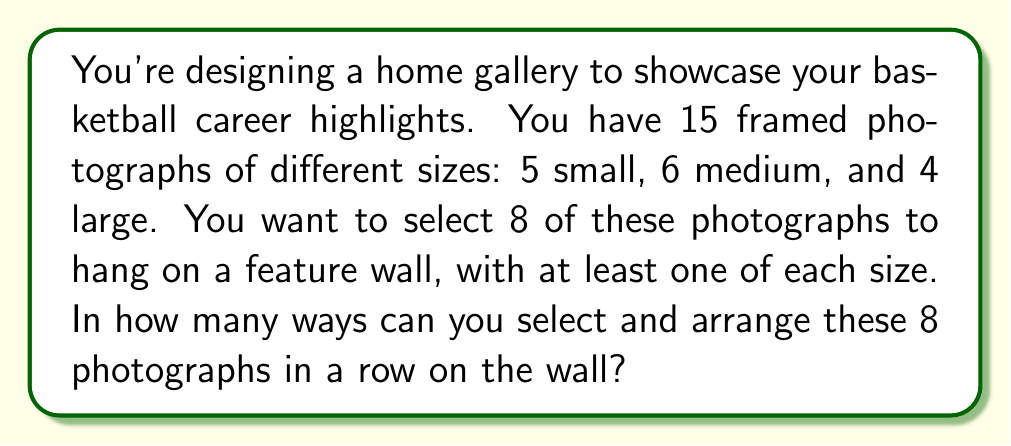Solve this math problem. Let's approach this step-by-step:

1) First, we need to select the photographs:
   - We must choose at least 1 small, 1 medium, and 1 large photograph.
   - Then, we need to choose 5 more from the remaining 12 photographs.

2) For the small photographs:
   - We must choose at least 1, and can choose up to 3 (since we need space for medium and large).
   - This can be represented as: $\binom{5}{1} + \binom{5}{2} + \binom{5}{3}$

3) For the medium photographs:
   - We must choose at least 1, and can choose up to 5.
   - This can be represented as: $\binom{6}{1} + \binom{6}{2} + \binom{6}{3} + \binom{6}{4} + \binom{6}{5}$

4) For the large photographs:
   - We must choose at least 1, and can choose up to 4.
   - This can be represented as: $\binom{4}{1} + \binom{4}{2} + \binom{4}{3} + \binom{4}{4}$

5) Using the multiplication principle, the total number of ways to select the photographs is:
   $$(\binom{5}{1} + \binom{5}{2} + \binom{5}{3})(\binom{6}{1} + \binom{6}{2} + \binom{6}{3} + \binom{6}{4} + \binom{6}{5})(\binom{4}{1} + \binom{4}{2} + \binom{4}{3} + \binom{4}{4})$$

6) Calculating this:
   $$(5 + 10 + 10)(6 + 15 + 20 + 15 + 6)(4 + 6 + 4 + 1) = 25 \cdot 62 \cdot 15 = 23,250$$

7) Now, for each selection, we need to arrange 8 photographs in a row.
   This can be done in 8! ways.

8) Therefore, the total number of ways to select and arrange the photographs is:
   $$23,250 \cdot 8! = 23,250 \cdot 40,320 = 938,160,000$$
Answer: 938,160,000 